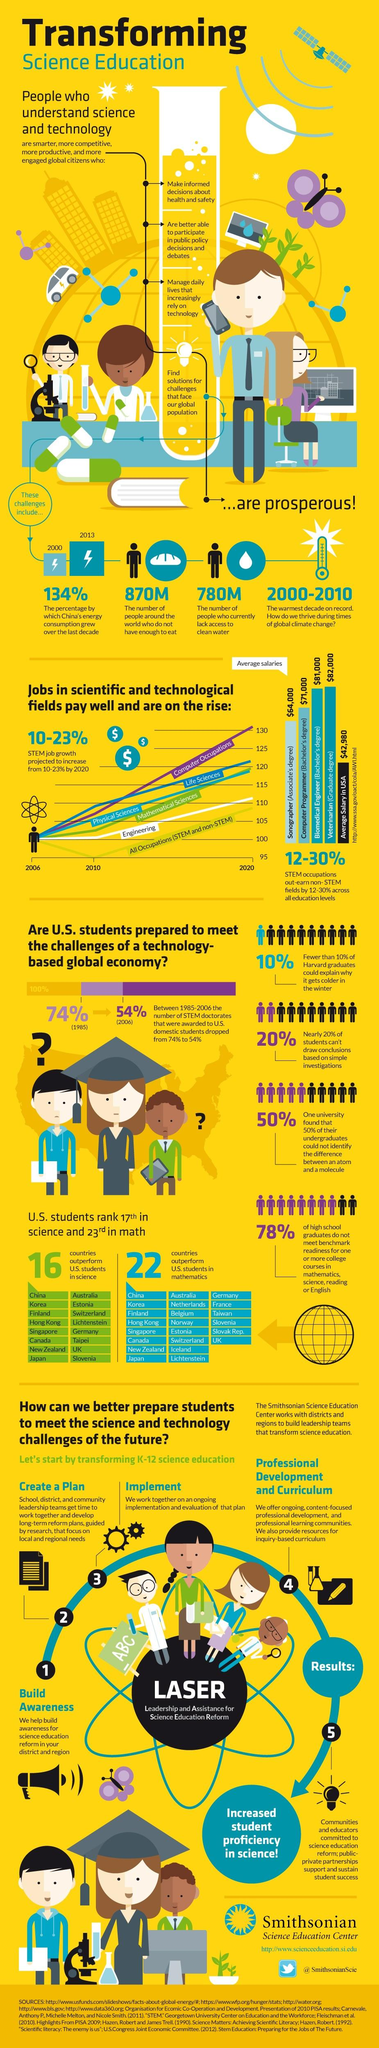Outline some significant characteristics in this image. It is estimated that approximately 870 million people lack access to adequate sanitation facilities, which poses significant public health and environmental risks. The average salary of a sonographer is higher when compared to the average salary in the USA, by 22,000 dollars. According to recent estimates, approximately 780 million people around the world lack access to clean water. The 2000s were the warmest decade in recorded history. According to the data, the performance of US students in mathematics is ranked 23rd when compared to other countries. 